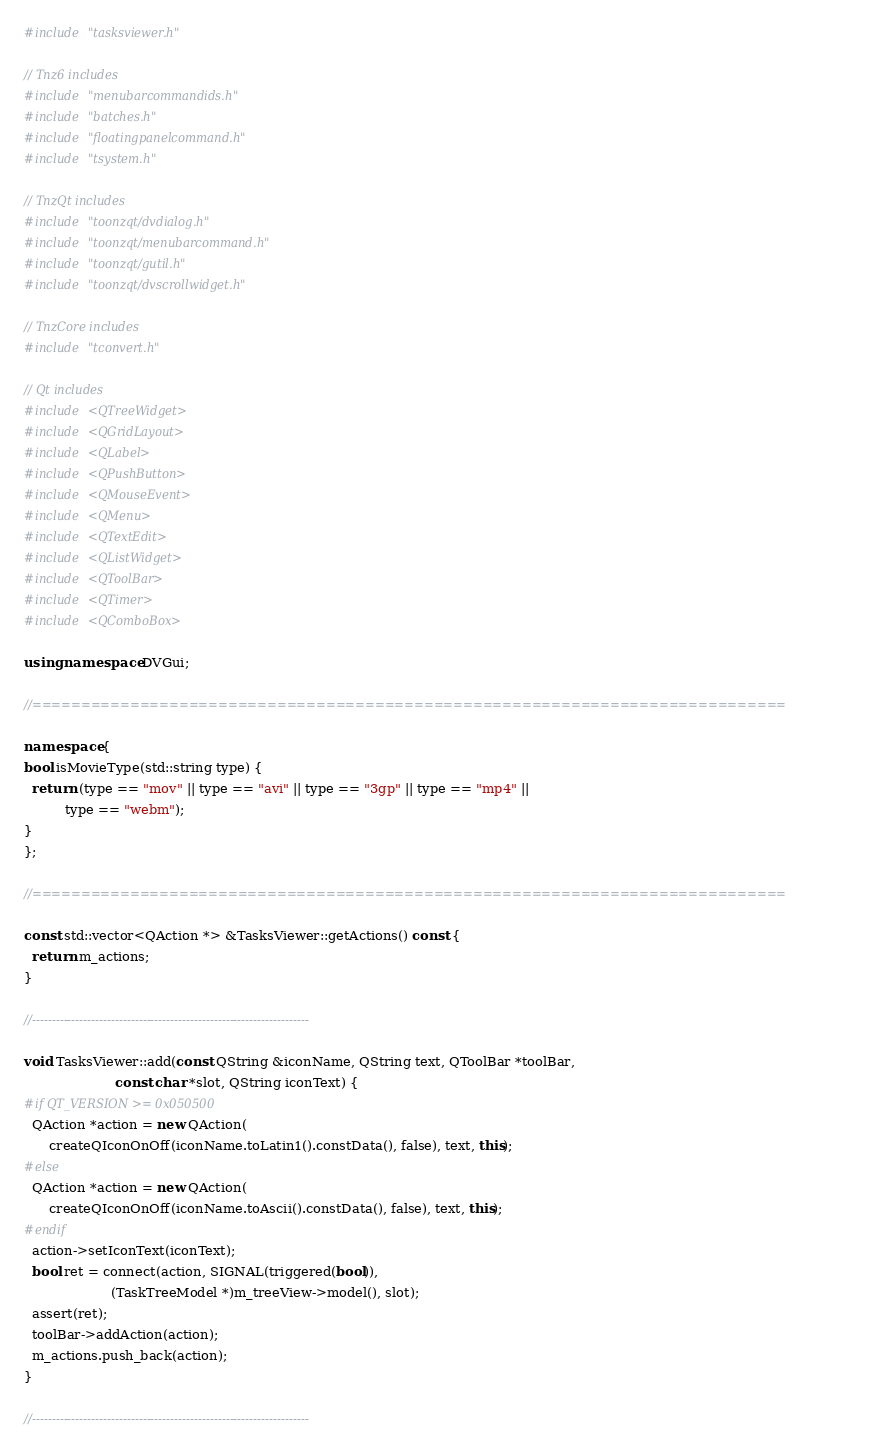Convert code to text. <code><loc_0><loc_0><loc_500><loc_500><_C++_>

#include "tasksviewer.h"

// Tnz6 includes
#include "menubarcommandids.h"
#include "batches.h"
#include "floatingpanelcommand.h"
#include "tsystem.h"

// TnzQt includes
#include "toonzqt/dvdialog.h"
#include "toonzqt/menubarcommand.h"
#include "toonzqt/gutil.h"
#include "toonzqt/dvscrollwidget.h"

// TnzCore includes
#include "tconvert.h"

// Qt includes
#include <QTreeWidget>
#include <QGridLayout>
#include <QLabel>
#include <QPushButton>
#include <QMouseEvent>
#include <QMenu>
#include <QTextEdit>
#include <QListWidget>
#include <QToolBar>
#include <QTimer>
#include <QComboBox>

using namespace DVGui;

//=============================================================================

namespace {
bool isMovieType(std::string type) {
  return (type == "mov" || type == "avi" || type == "3gp" || type == "mp4" ||
          type == "webm");
}
};

//=============================================================================

const std::vector<QAction *> &TasksViewer::getActions() const {
  return m_actions;
}

//----------------------------------------------------------------------

void TasksViewer::add(const QString &iconName, QString text, QToolBar *toolBar,
                      const char *slot, QString iconText) {
#if QT_VERSION >= 0x050500
  QAction *action = new QAction(
      createQIconOnOff(iconName.toLatin1().constData(), false), text, this);
#else
  QAction *action = new QAction(
      createQIconOnOff(iconName.toAscii().constData(), false), text, this);
#endif
  action->setIconText(iconText);
  bool ret = connect(action, SIGNAL(triggered(bool)),
                     (TaskTreeModel *)m_treeView->model(), slot);
  assert(ret);
  toolBar->addAction(action);
  m_actions.push_back(action);
}

//----------------------------------------------------------------------
</code> 